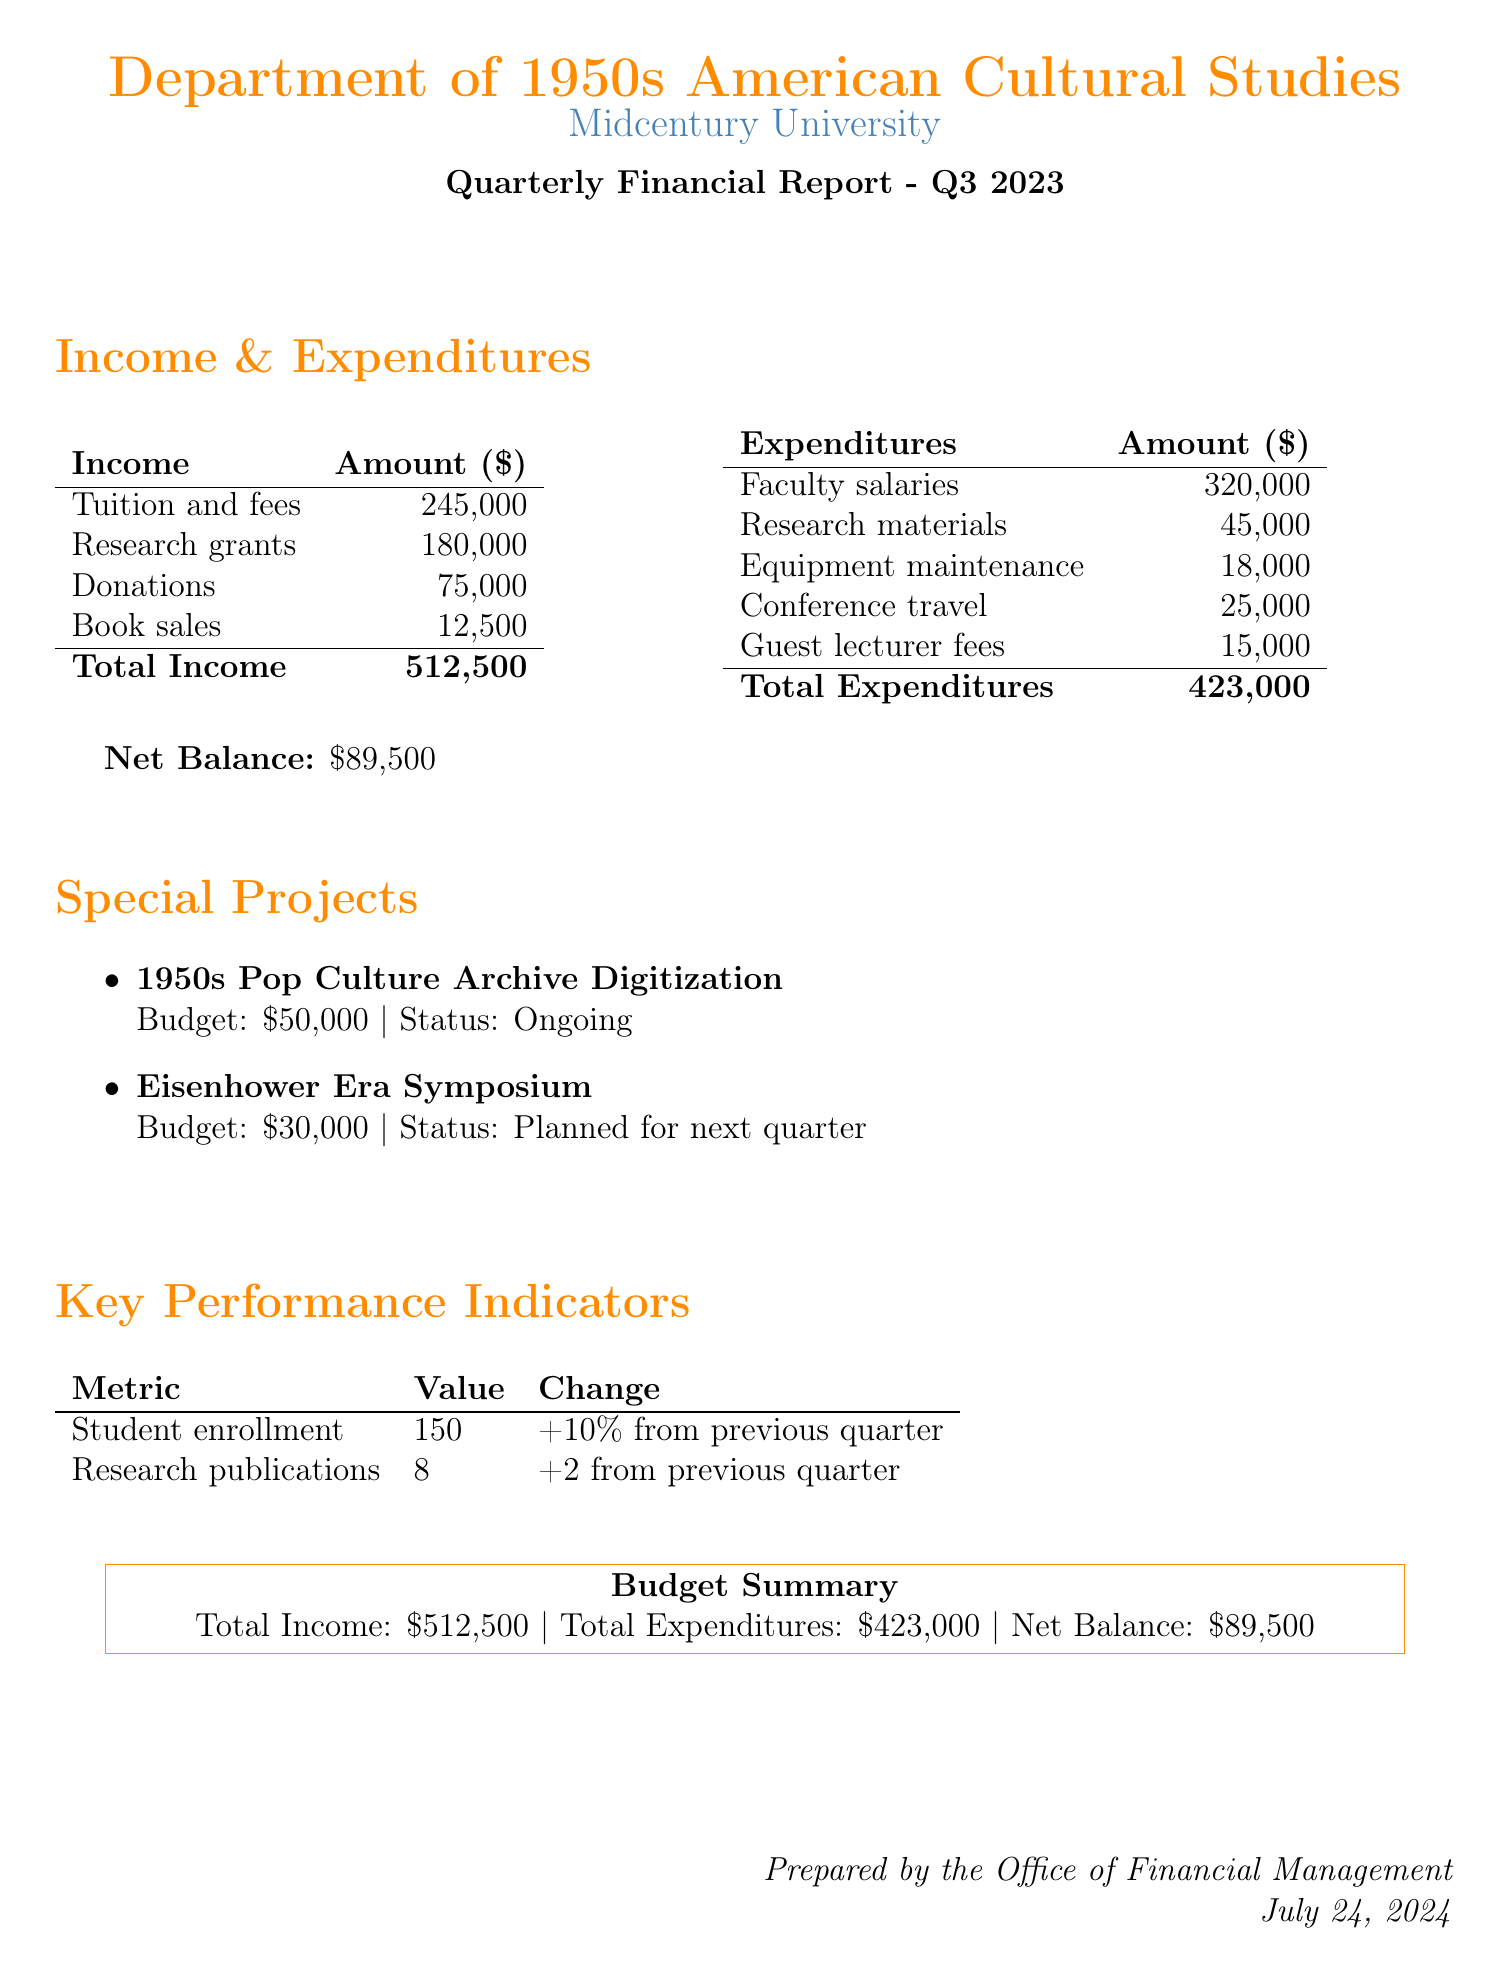what is the total income? The total income is calculated by adding all income sources together: $245,000 + $180,000 + $75,000 + $12,500 = $512,500.
Answer: $512,500 what is the amount spent on faculty salaries? The amount spent on faculty salaries is detailed in the expenditures section of the document.
Answer: $320,000 how many research publications were made? The number of research publications is provided under key performance indicators in the document.
Answer: 8 what is the status of the "Eisenhower Era Symposium"? The status of the "Eisenhower Era Symposium" is mentioned in the special projects section of the document.
Answer: Planned for next quarter what is the net balance for this quarter? The net balance is the difference between total income and total expenditures, provided at the end of the budget summary section.
Answer: $89,500 how much is allocated for the "1950s Pop Culture Archive Digitization"? The budget for the "1950s Pop Culture Archive Digitization" is listed under special projects in the document.
Answer: $50,000 what is the percentage change in student enrollment? The percentage change in student enrollment is provided in the key performance indicators section of the document.
Answer: +10% how much was spent on conference travel? The expenditure for conference travel is specified in the expenditures section of the document.
Answer: $25,000 what are total expenditures? Total expenditures are found by summing all expenditure categories in the document.
Answer: $423,000 